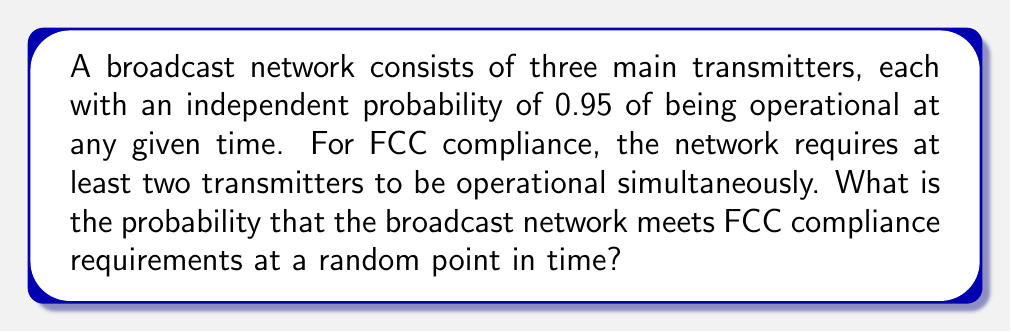What is the answer to this math problem? Let's approach this step-by-step:

1) First, we need to define our random variable. Let X be the number of operational transmitters at any given time.

2) We know that each transmitter has a probability of 0.95 of being operational independently. This scenario follows a binomial distribution with n = 3 (total number of transmitters) and p = 0.95 (probability of each transmitter being operational).

3) For FCC compliance, we need at least 2 transmitters to be operational. So we need to find P(X ≥ 2).

4) We can calculate this as: P(X ≥ 2) = P(X = 2) + P(X = 3)

5) For a binomial distribution, the probability of exactly k successes in n trials is given by:

   $$P(X = k) = \binom{n}{k} p^k (1-p)^{n-k}$$

6) Let's calculate P(X = 2):
   $$P(X = 2) = \binom{3}{2} (0.95)^2 (0.05) = 3 * 0.9025 * 0.05 = 0.135375$$

7) Now, let's calculate P(X = 3):
   $$P(X = 3) = \binom{3}{3} (0.95)^3 = 1 * 0.857375 = 0.857375$$

8) Therefore, P(X ≥ 2) = P(X = 2) + P(X = 3) = 0.135375 + 0.857375 = 0.99275
Answer: 0.99275 